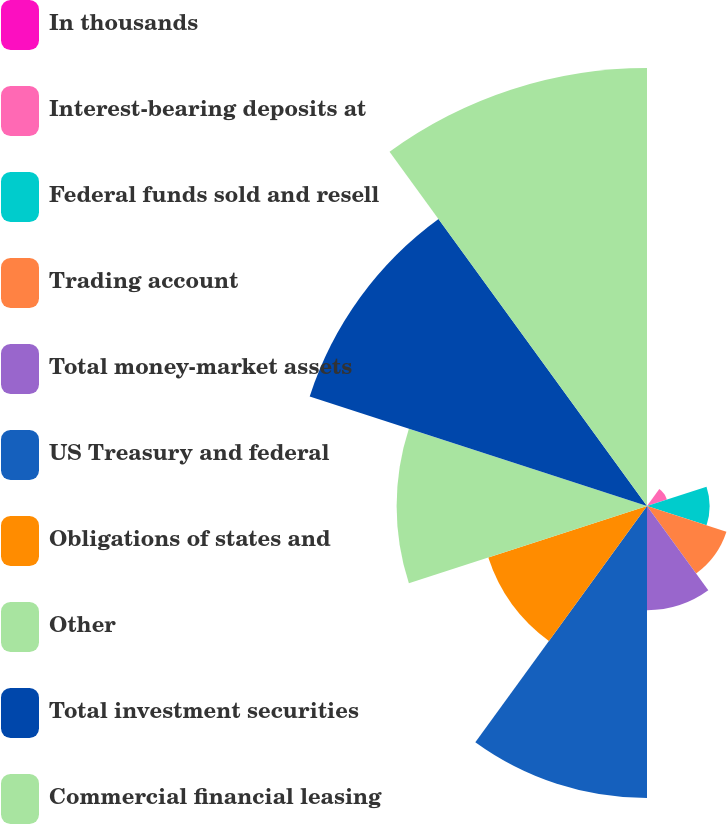Convert chart to OTSL. <chart><loc_0><loc_0><loc_500><loc_500><pie_chart><fcel>In thousands<fcel>Interest-bearing deposits at<fcel>Federal funds sold and resell<fcel>Trading account<fcel>Total money-market assets<fcel>US Treasury and federal<fcel>Obligations of states and<fcel>Other<fcel>Total investment securities<fcel>Commercial financial leasing<nl><fcel>0.0%<fcel>1.18%<fcel>3.53%<fcel>4.71%<fcel>5.88%<fcel>16.47%<fcel>9.41%<fcel>14.12%<fcel>20.0%<fcel>24.7%<nl></chart> 